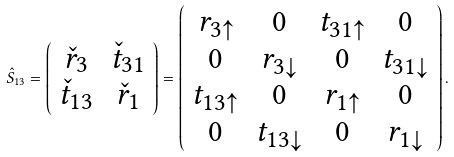<formula> <loc_0><loc_0><loc_500><loc_500>\hat { S } _ { 1 3 } = \left ( \begin{array} { c c } \check { r } _ { 3 } & \check { t } _ { 3 1 } \\ \check { t } _ { 1 3 } & \check { r } _ { 1 } \end{array} \right ) = \left ( \begin{array} { c c c c } r _ { 3 \uparrow } & 0 & t _ { 3 1 \uparrow } & 0 \\ 0 & r _ { 3 \downarrow } & 0 & t _ { 3 1 \downarrow } \\ t _ { 1 3 \uparrow } & 0 & r _ { 1 \uparrow } & 0 \\ 0 & t _ { 1 3 \downarrow } & 0 & r _ { 1 \downarrow } \end{array} \right ) .</formula> 